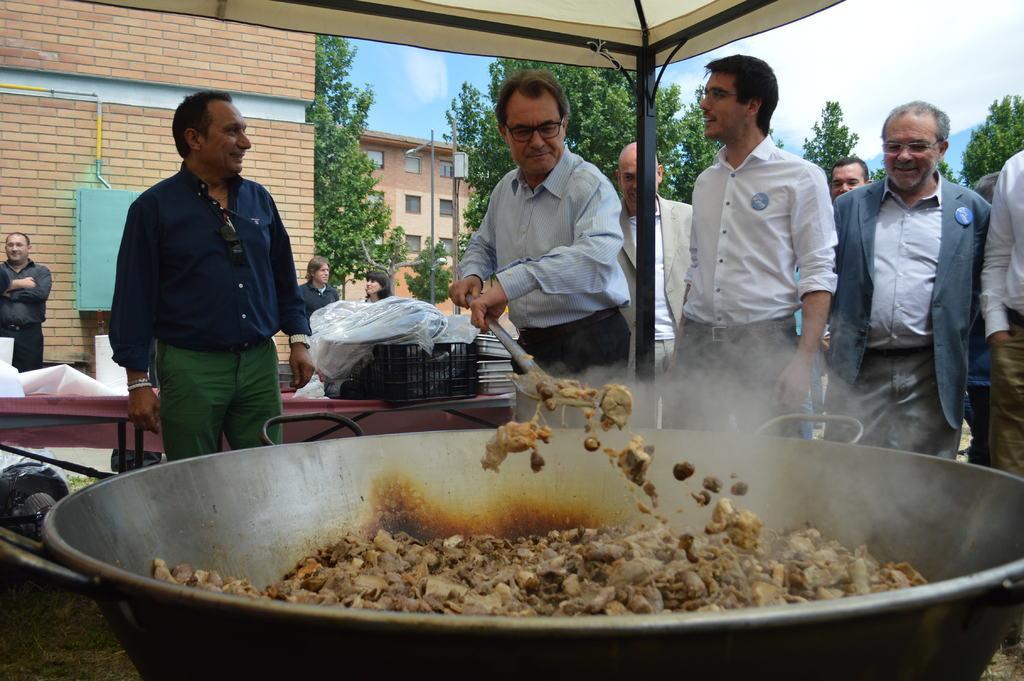In one or two sentences, can you explain what this image depicts? In the picture we can see a big bowl on the stove with meat and a man cooking it with a big spoon and besides him we can see some people are standing and they are smiling and they are under the shed and behind it, we can see a building and beside it, we can see some trees and behind it also we can see some buildings and in the background we can see a sky with clouds. 